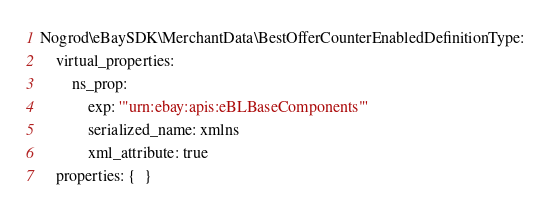<code> <loc_0><loc_0><loc_500><loc_500><_YAML_>Nogrod\eBaySDK\MerchantData\BestOfferCounterEnabledDefinitionType:
    virtual_properties:
        ns_prop:
            exp: '"urn:ebay:apis:eBLBaseComponents"'
            serialized_name: xmlns
            xml_attribute: true
    properties: {  }
</code> 